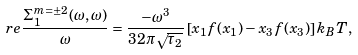Convert formula to latex. <formula><loc_0><loc_0><loc_500><loc_500>\ r e \frac { \Sigma _ { 1 } ^ { m = \pm 2 } ( \omega , \omega ) } { \omega } = \frac { - \omega ^ { 3 } } { 3 2 \pi \sqrt { \tau _ { 2 } } } \left [ x _ { 1 } f ( x _ { 1 } ) - x _ { 3 } f ( x _ { 3 } ) \right ] k _ { B } T ,</formula> 